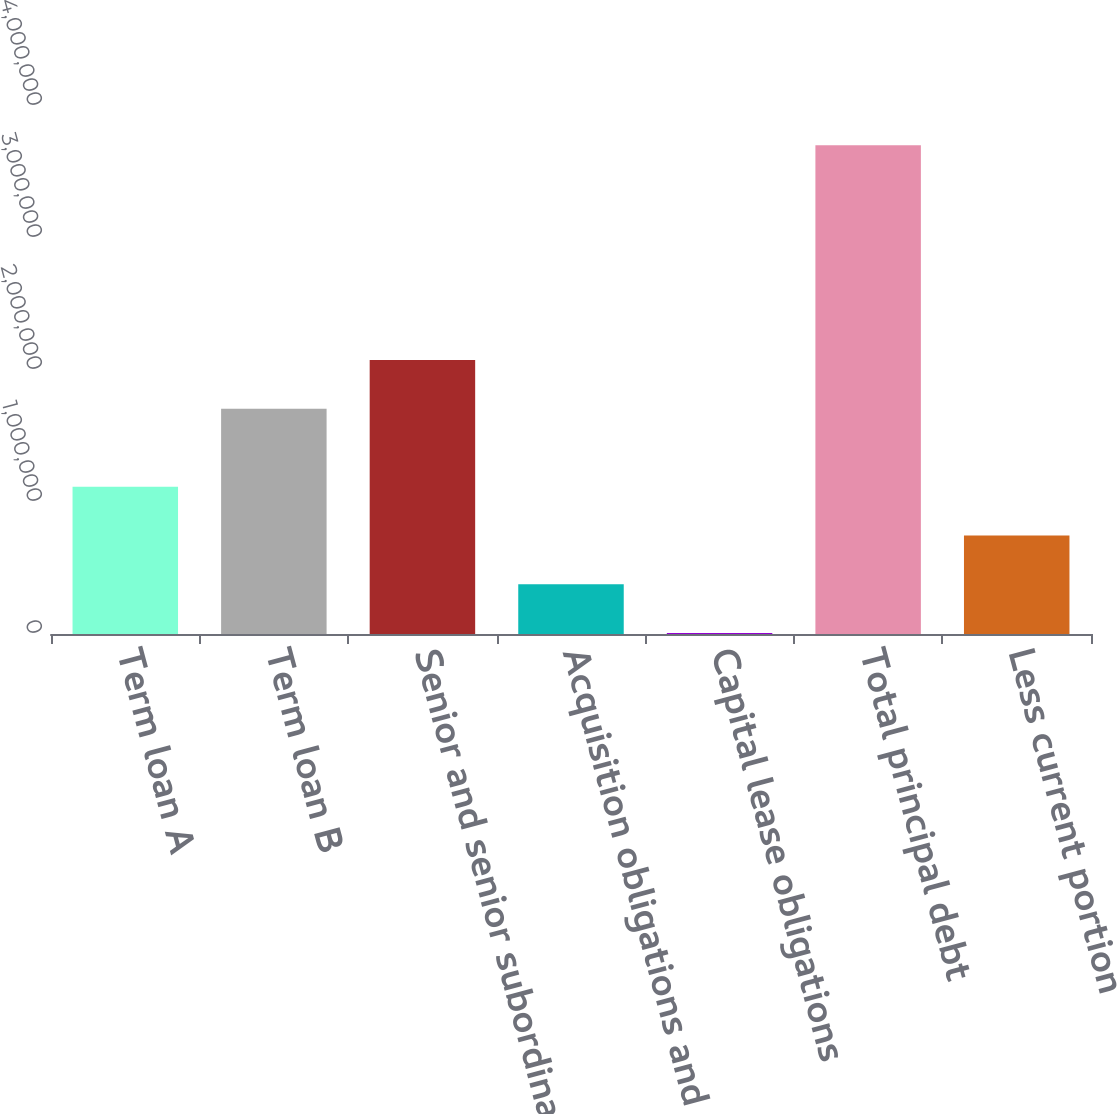<chart> <loc_0><loc_0><loc_500><loc_500><bar_chart><fcel>Term loan A<fcel>Term loan B<fcel>Senior and senior subordinated<fcel>Acquisition obligations and<fcel>Capital lease obligations<fcel>Total principal debt<fcel>Less current portion<nl><fcel>1.11552e+06<fcel>1.70588e+06<fcel>2.07549e+06<fcel>376284<fcel>6667<fcel>3.70284e+06<fcel>745901<nl></chart> 